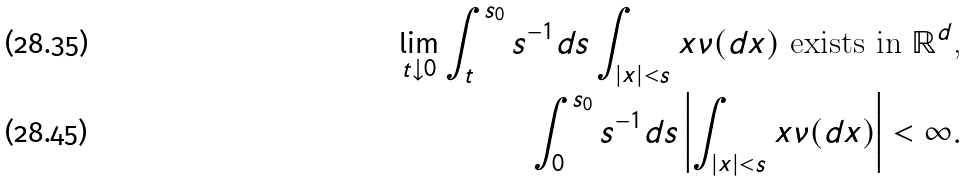Convert formula to latex. <formula><loc_0><loc_0><loc_500><loc_500>\lim _ { t \downarrow 0 } \int _ { t } ^ { s _ { 0 } } s ^ { - 1 } d s \int _ { | x | < s } x \nu ( d x ) \text { exists in $\mathbb{R}^{d}$,} \\ \int _ { 0 } ^ { s _ { 0 } } s ^ { - 1 } d s \left | \int _ { | x | < s } x \nu ( d x ) \right | < \infty .</formula> 